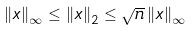<formula> <loc_0><loc_0><loc_500><loc_500>\left \| x \right \| _ { \infty } \leq \left \| x \right \| _ { 2 } \leq { \sqrt { n } } \left \| x \right \| _ { \infty }</formula> 